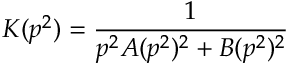Convert formula to latex. <formula><loc_0><loc_0><loc_500><loc_500>K ( p ^ { 2 } ) = \frac { 1 } { p ^ { 2 } A ( p ^ { 2 } ) ^ { 2 } + B ( p ^ { 2 } ) ^ { 2 } }</formula> 